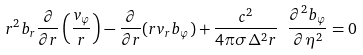Convert formula to latex. <formula><loc_0><loc_0><loc_500><loc_500>r ^ { 2 } b _ { r } \frac { \partial } { \partial r } \left ( \frac { v _ { \varphi } } { r } \right ) - \frac { \partial } { \partial r } ( r v _ { r } b _ { \varphi } ) + \frac { c ^ { 2 } } { 4 \pi \sigma \Delta ^ { 2 } r } \ \frac { \partial ^ { 2 } b _ { \varphi } } { \partial \eta ^ { 2 } } = 0</formula> 